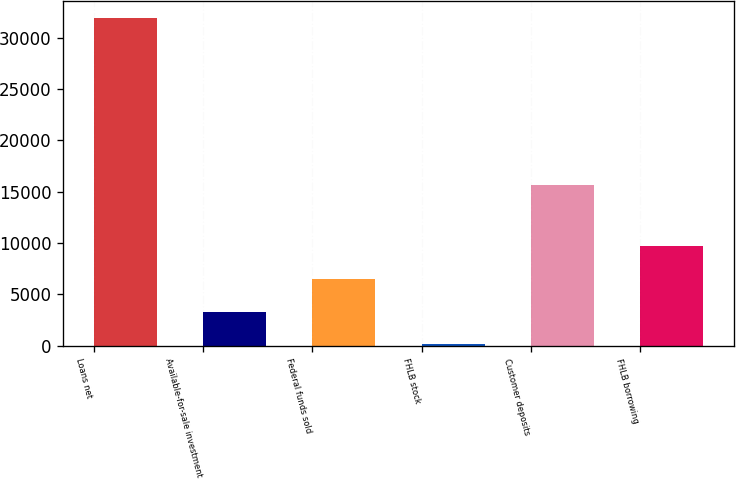<chart> <loc_0><loc_0><loc_500><loc_500><bar_chart><fcel>Loans net<fcel>Available-for-sale investment<fcel>Federal funds sold<fcel>FHLB stock<fcel>Customer deposits<fcel>FHLB borrowing<nl><fcel>31949<fcel>3307.4<fcel>6489.8<fcel>125<fcel>15634<fcel>9672.2<nl></chart> 